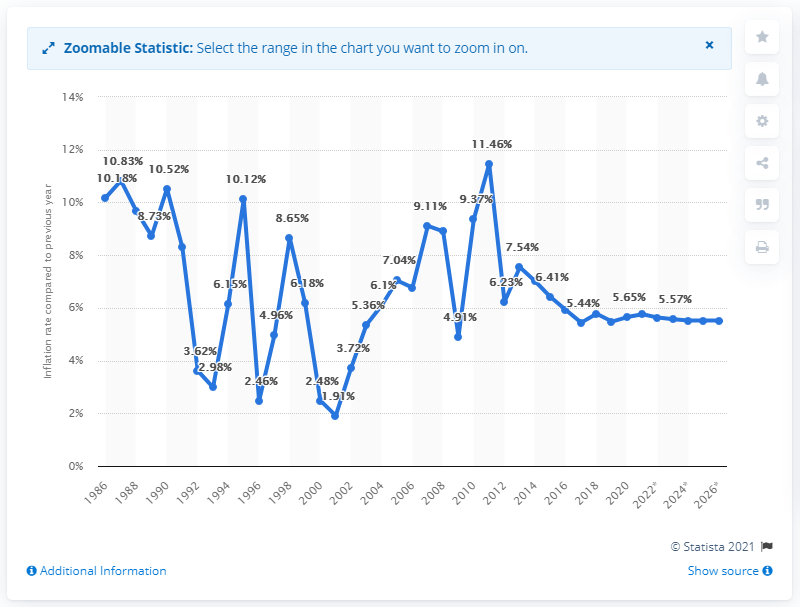Identify some key points in this picture. The inflation rate in Bangladesh is expected to be 5.52% for the next few years. 